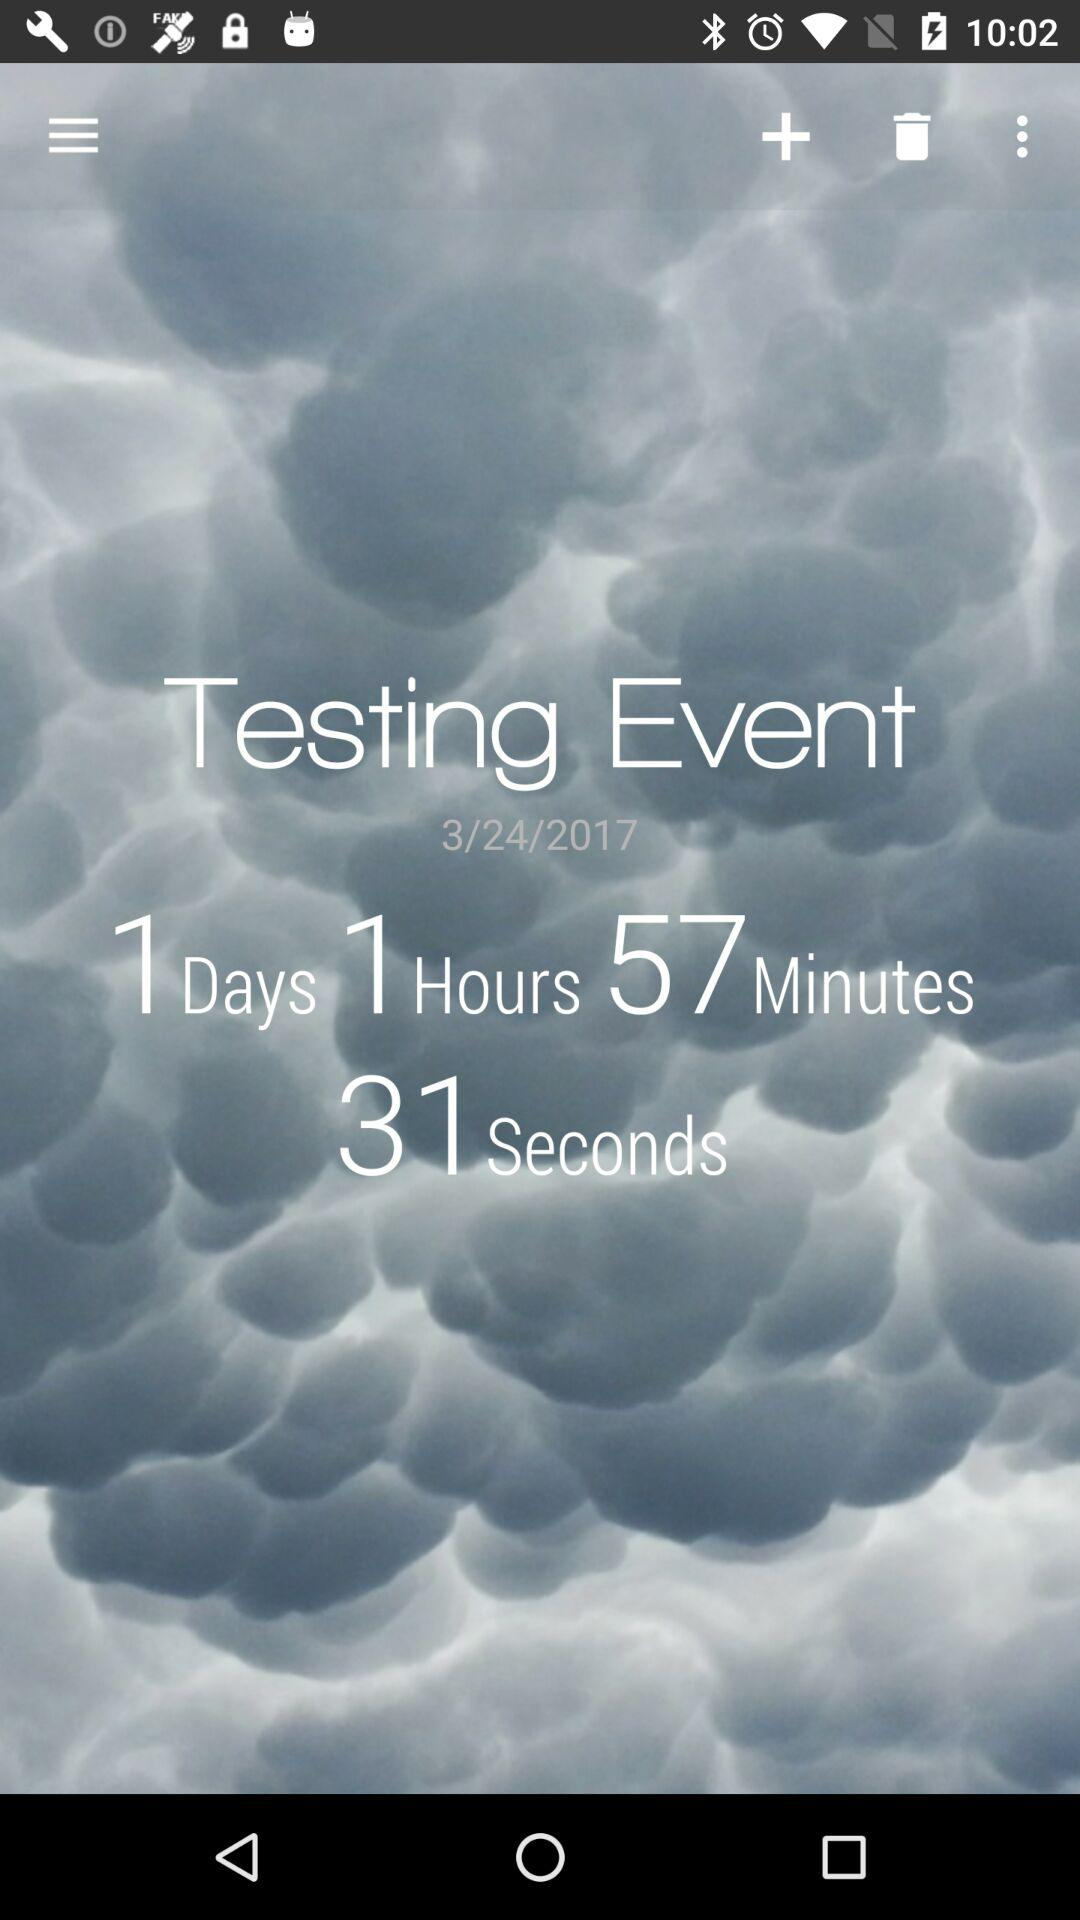What is the name of the event? The name of the event is "Testing Event". 